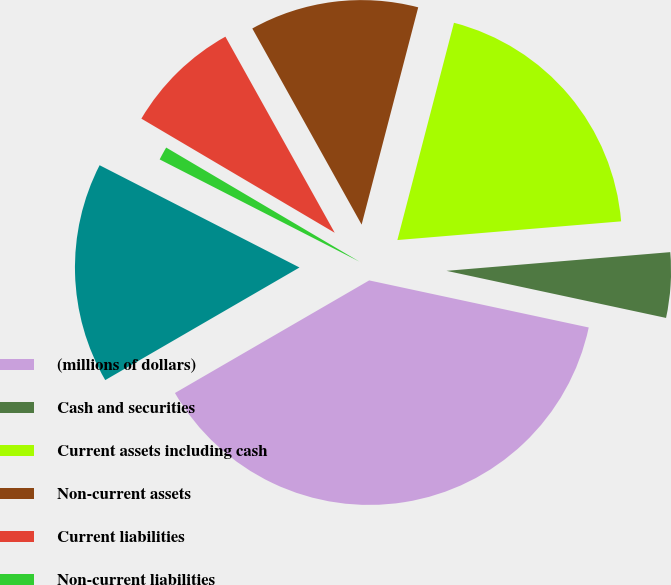<chart> <loc_0><loc_0><loc_500><loc_500><pie_chart><fcel>(millions of dollars)<fcel>Cash and securities<fcel>Current assets including cash<fcel>Non-current assets<fcel>Current liabilities<fcel>Non-current liabilities<fcel>Total equity<nl><fcel>38.28%<fcel>4.69%<fcel>19.62%<fcel>12.15%<fcel>8.42%<fcel>0.96%<fcel>15.89%<nl></chart> 